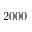<formula> <loc_0><loc_0><loc_500><loc_500>2 0 0 0</formula> 